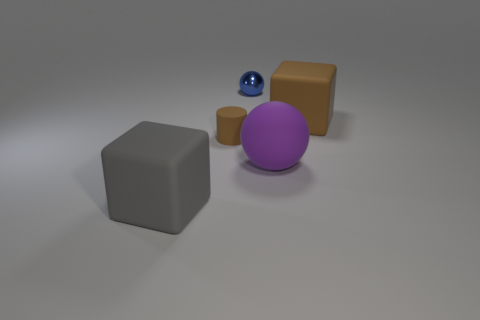Is there any other thing that is the same shape as the large purple matte thing?
Your answer should be very brief. Yes. What is the shape of the brown thing left of the matte block that is right of the large purple matte object?
Provide a short and direct response. Cylinder. There is a gray thing that is made of the same material as the purple thing; what shape is it?
Ensure brevity in your answer.  Cube. There is a cube on the left side of the matte block that is on the right side of the blue ball; what size is it?
Your response must be concise. Large. The purple matte thing is what shape?
Ensure brevity in your answer.  Sphere. What number of tiny objects are either gray cubes or yellow shiny balls?
Keep it short and to the point. 0. What size is the other thing that is the same shape as the blue metallic thing?
Keep it short and to the point. Large. What number of big matte blocks are behind the purple rubber sphere and in front of the small rubber cylinder?
Offer a very short reply. 0. Do the metallic thing and the big purple rubber thing in front of the brown cylinder have the same shape?
Provide a short and direct response. Yes. Is the number of brown objects that are left of the big brown thing greater than the number of big red rubber spheres?
Provide a succinct answer. Yes. 